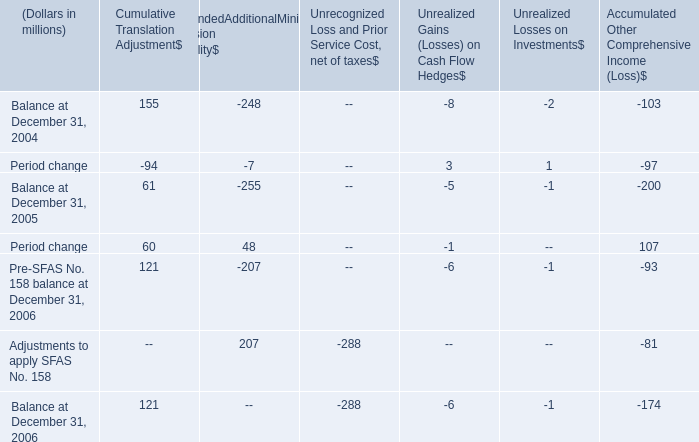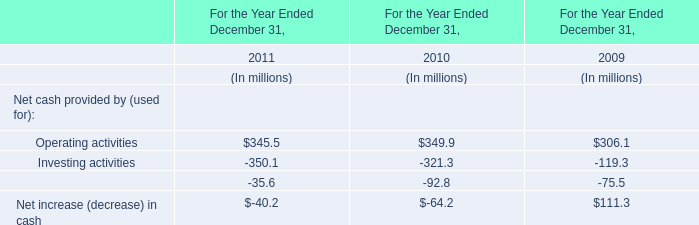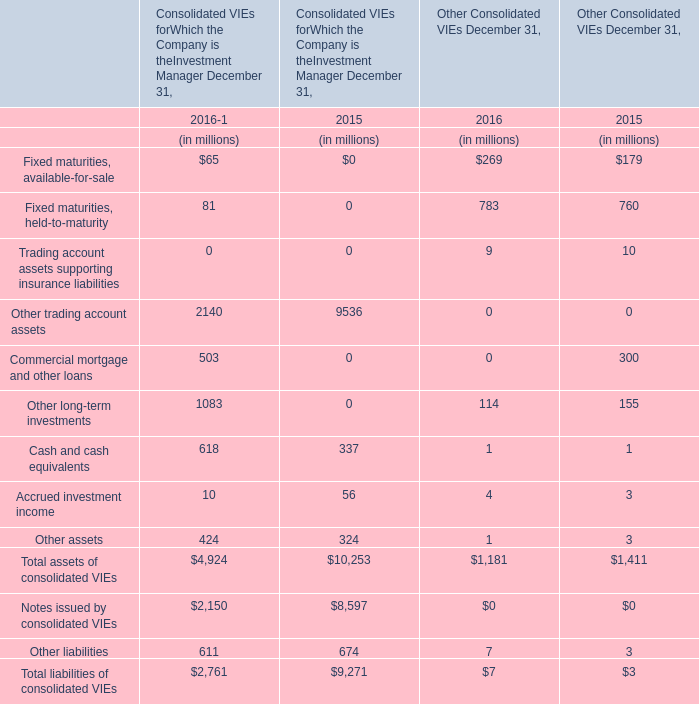what is the percent change in cumulative translation adjustment between 2004 and 2006? 
Computations: ((121 - 155) / 155)
Answer: -0.21935. 